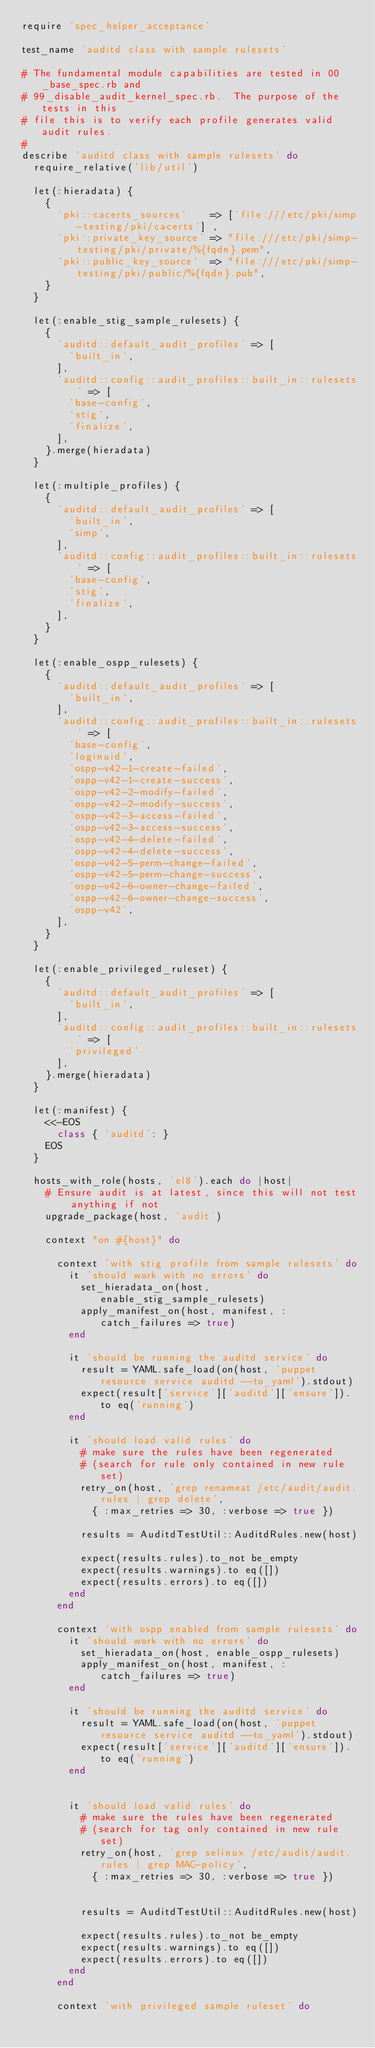<code> <loc_0><loc_0><loc_500><loc_500><_Ruby_>require 'spec_helper_acceptance'

test_name 'auditd class with sample rulesets'

# The fundamental module capabilities are tested in 00_base_spec.rb and
# 99_disable_audit_kernel_spec.rb.  The purpose of the tests in this
# file this is to verify each profile generates valid audit rules.
#
describe 'auditd class with sample rulesets' do
  require_relative('lib/util')

  let(:hieradata) {
    {
      'pki::cacerts_sources'    => ['file:///etc/pki/simp-testing/pki/cacerts'] ,
      'pki::private_key_source' => "file:///etc/pki/simp-testing/pki/private/%{fqdn}.pem",
      'pki::public_key_source'  => "file:///etc/pki/simp-testing/pki/public/%{fqdn}.pub",
    }
  }

  let(:enable_stig_sample_rulesets) {
    {
      'auditd::default_audit_profiles' => [
        'built_in',
      ],
      'auditd::config::audit_profiles::built_in::rulesets' => [
        'base-config',
        'stig',
        'finalize',
      ],
    }.merge(hieradata)
  }

  let(:multiple_profiles) {
    {
      'auditd::default_audit_profiles' => [
        'built_in',
        'simp',
      ],
      'auditd::config::audit_profiles::built_in::rulesets' => [
        'base-config',
        'stig',
        'finalize',
      ],
    }
  }

  let(:enable_ospp_rulesets) {
    {
      'auditd::default_audit_profiles' => [
        'built_in',
      ],
      'auditd::config::audit_profiles::built_in::rulesets' => [
        'base-config',
        'loginuid',
        'ospp-v42-1-create-failed',
        'ospp-v42-1-create-success',
        'ospp-v42-2-modify-failed',
        'ospp-v42-2-modify-success',
        'ospp-v42-3-access-failed',
        'ospp-v42-3-access-success',
        'ospp-v42-4-delete-failed',
        'ospp-v42-4-delete-success',
        'ospp-v42-5-perm-change-failed',
        'ospp-v42-5-perm-change-success',
        'ospp-v42-6-owner-change-failed',
        'ospp-v42-6-owner-change-success',
        'ospp-v42',
      ],
    }
  }

  let(:enable_privileged_ruleset) {
    {
      'auditd::default_audit_profiles' => [
        'built_in',
      ],
      'auditd::config::audit_profiles::built_in::rulesets' => [
        'privileged'
      ],
    }.merge(hieradata)
  }

  let(:manifest) {
    <<-EOS
      class { 'auditd': }
    EOS
  }

  hosts_with_role(hosts, 'el8').each do |host|
    # Ensure audit is at latest, since this will not test anything if not
    upgrade_package(host, 'audit')

    context "on #{host}" do

      context 'with stig profile from sample rulesets' do
        it 'should work with no errors' do
          set_hieradata_on(host, enable_stig_sample_rulesets)
          apply_manifest_on(host, manifest, :catch_failures => true)
        end

        it 'should be running the auditd service' do
          result = YAML.safe_load(on(host, 'puppet resource service auditd --to_yaml').stdout)
          expect(result['service']['auditd']['ensure']).to eq('running')
        end

        it 'should load valid rules' do
          # make sure the rules have been regenerated
          # (search for rule only contained in new rule set)
          retry_on(host, 'grep renameat /etc/audit/audit.rules | grep delete',
            { :max_retries => 30, :verbose => true })

          results = AuditdTestUtil::AuditdRules.new(host)

          expect(results.rules).to_not be_empty
          expect(results.warnings).to eq([])
          expect(results.errors).to eq([])
        end
      end

      context 'with ospp enabled from sample rulesets' do
        it 'should work with no errors' do
          set_hieradata_on(host, enable_ospp_rulesets)
          apply_manifest_on(host, manifest, :catch_failures => true)
        end

        it 'should be running the auditd service' do
          result = YAML.safe_load(on(host, 'puppet resource service auditd --to_yaml').stdout)
          expect(result['service']['auditd']['ensure']).to eq('running')
        end


        it 'should load valid rules' do
          # make sure the rules have been regenerated
          # (search for tag only contained in new rule set)
          retry_on(host, 'grep selinux /etc/audit/audit.rules | grep MAC-policy',
            { :max_retries => 30, :verbose => true })


          results = AuditdTestUtil::AuditdRules.new(host)

          expect(results.rules).to_not be_empty
          expect(results.warnings).to eq([])
          expect(results.errors).to eq([])
        end
      end

      context 'with privileged sample ruleset' do</code> 